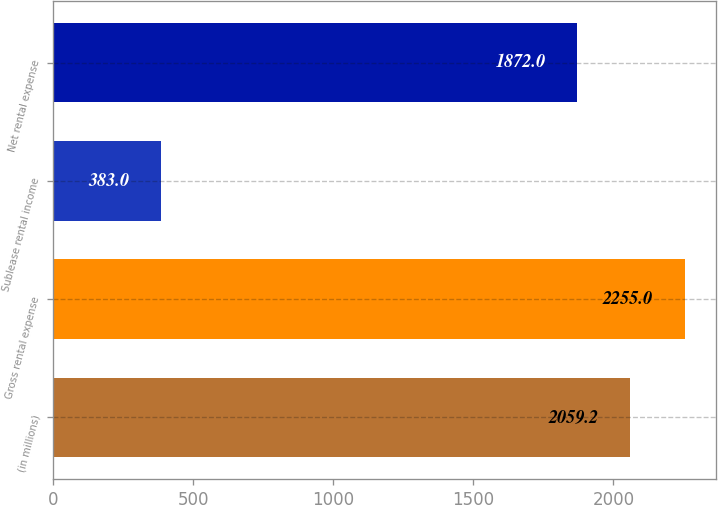<chart> <loc_0><loc_0><loc_500><loc_500><bar_chart><fcel>(in millions)<fcel>Gross rental expense<fcel>Sublease rental income<fcel>Net rental expense<nl><fcel>2059.2<fcel>2255<fcel>383<fcel>1872<nl></chart> 